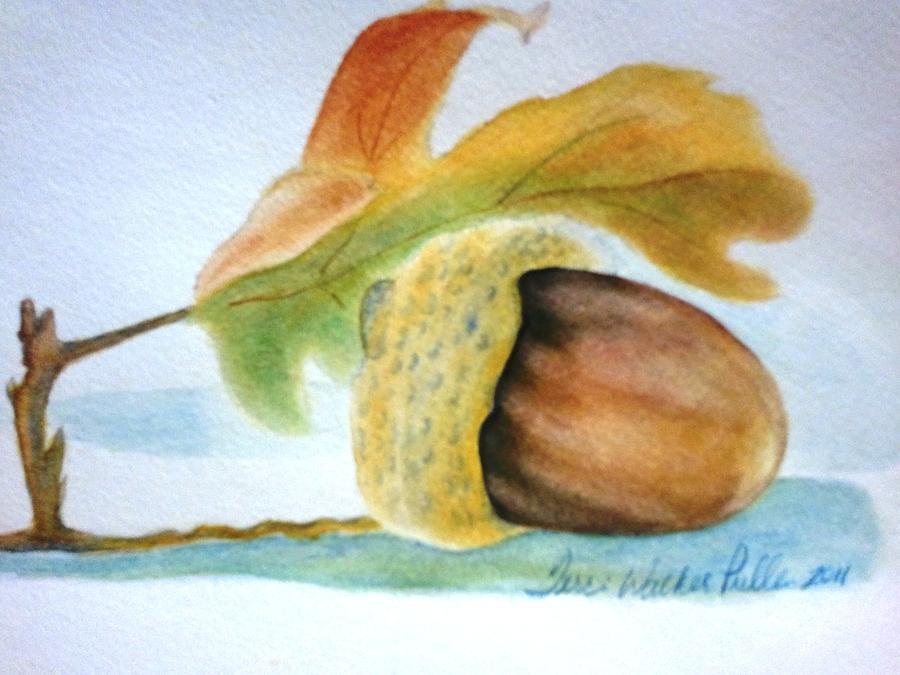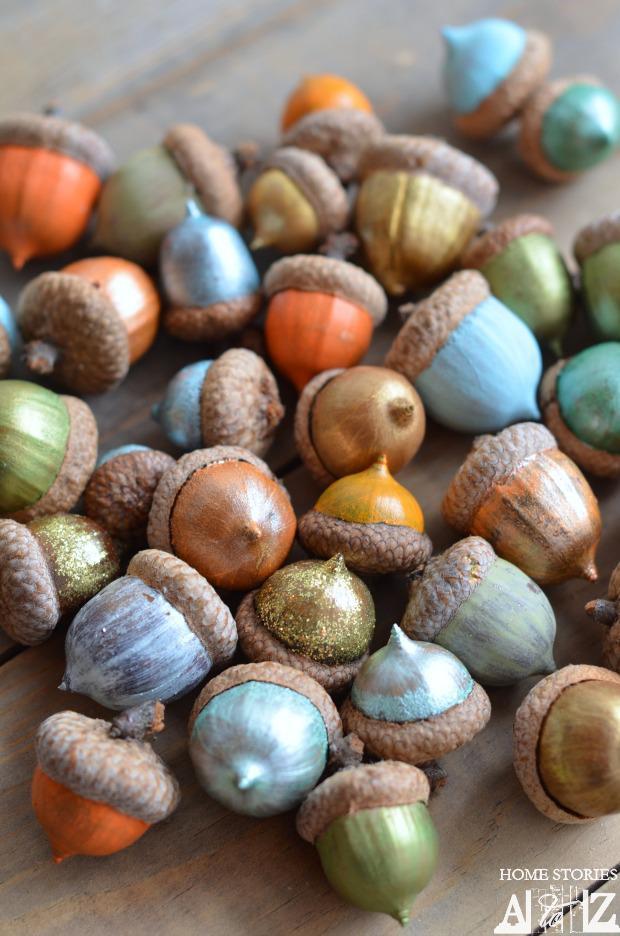The first image is the image on the left, the second image is the image on the right. Considering the images on both sides, is "There is only a single acorn it at least one of the images." valid? Answer yes or no. Yes. 